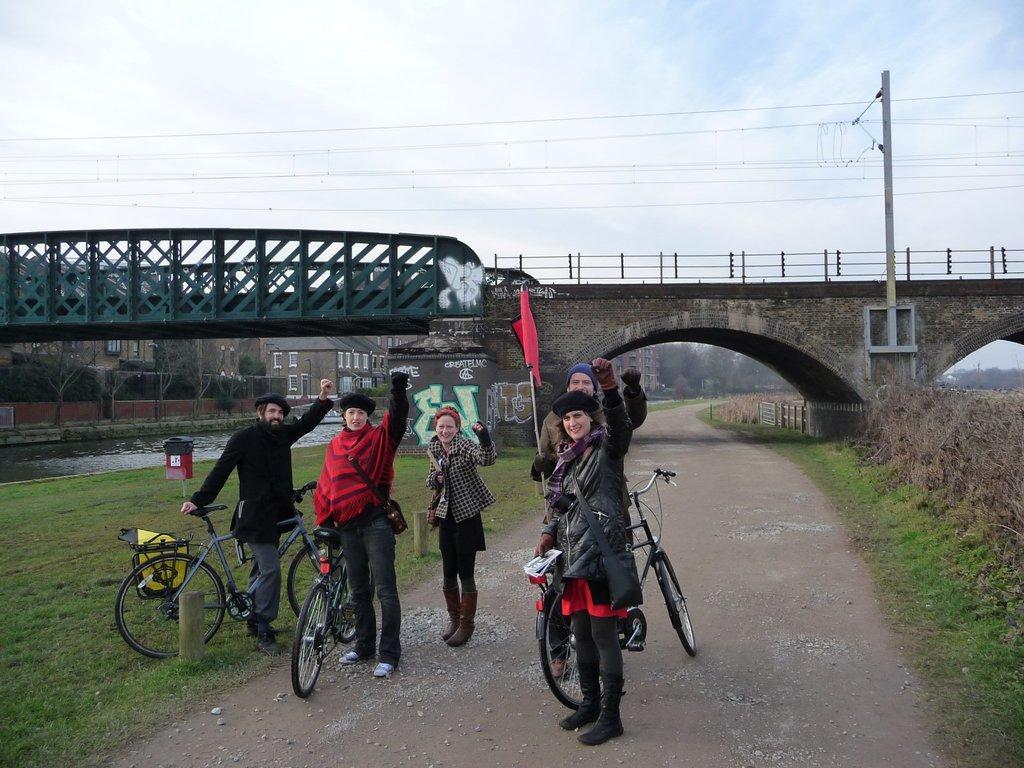In one or two sentences, can you explain what this image depicts? In the center of the image we can see people with bicycles standing on the road. In the background we can see a bridge, a river, a trash bin on the grass. At the top there is a sky with clouds. We can also see an electrical pole with wires. 